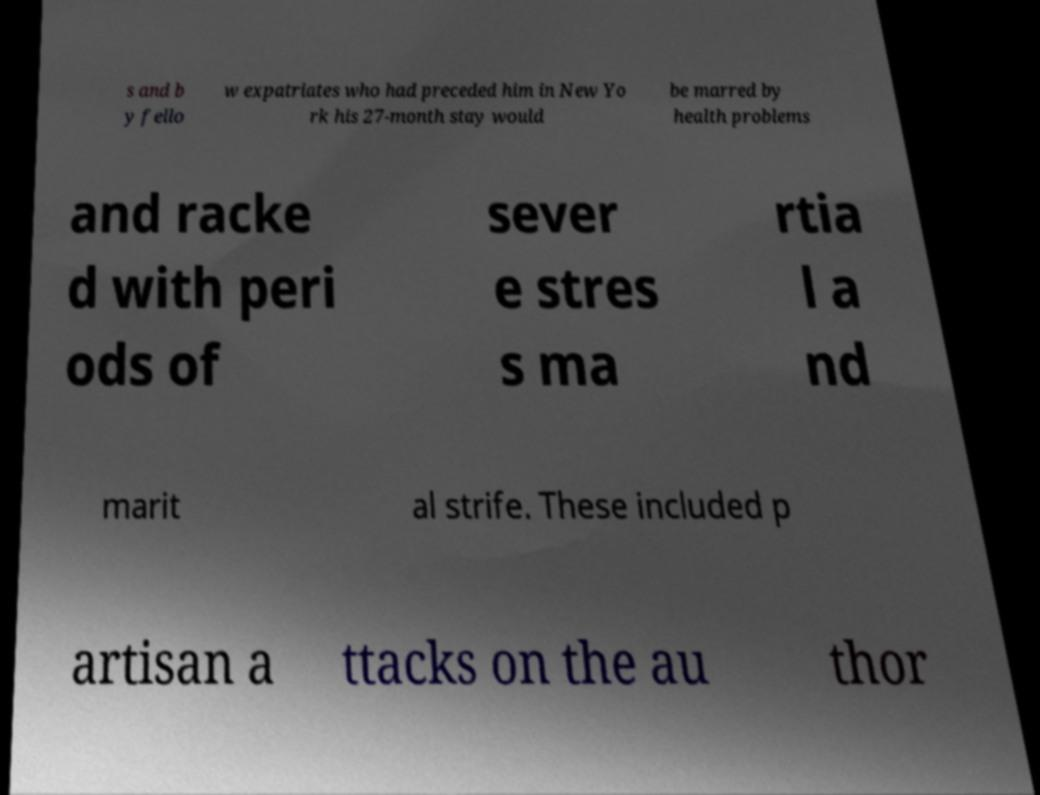Can you read and provide the text displayed in the image?This photo seems to have some interesting text. Can you extract and type it out for me? s and b y fello w expatriates who had preceded him in New Yo rk his 27-month stay would be marred by health problems and racke d with peri ods of sever e stres s ma rtia l a nd marit al strife. These included p artisan a ttacks on the au thor 